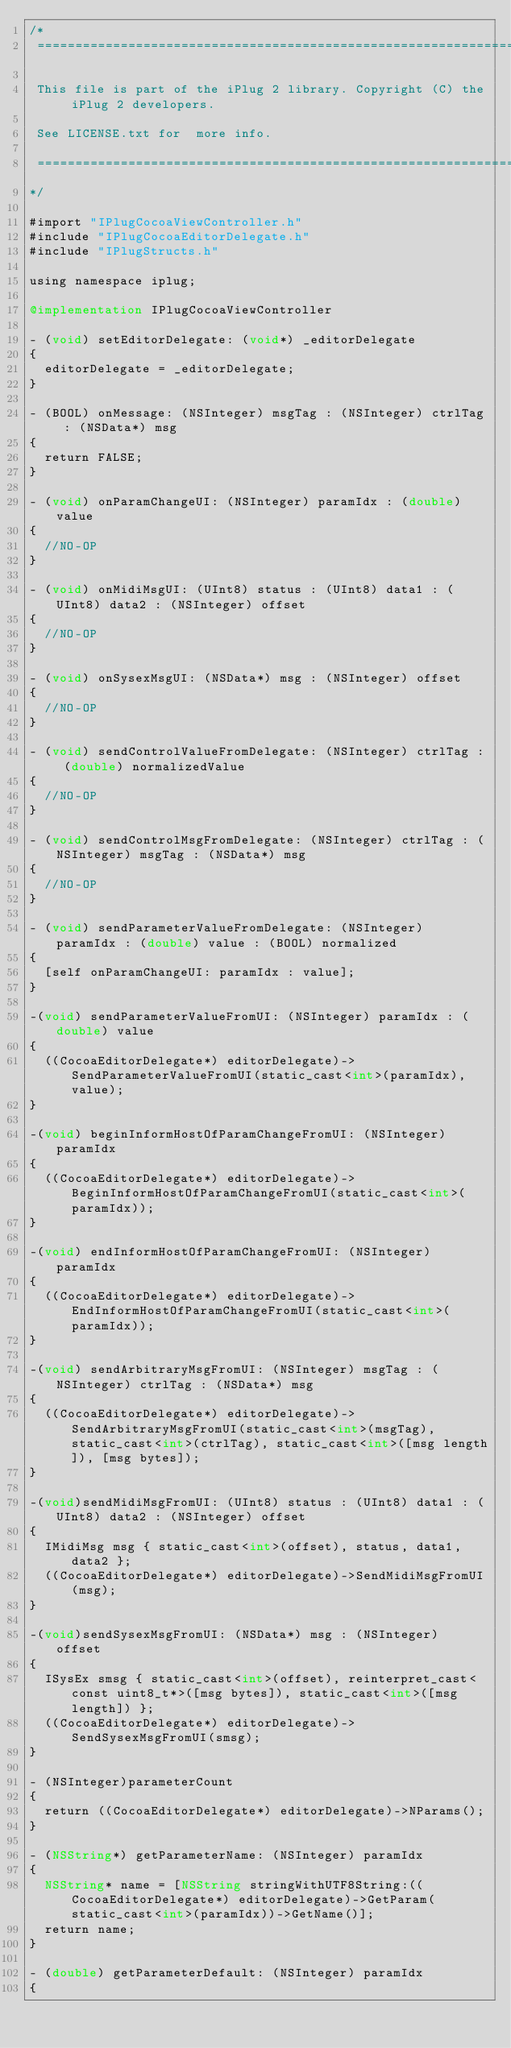<code> <loc_0><loc_0><loc_500><loc_500><_ObjectiveC_>/*
 ==============================================================================
 
 This file is part of the iPlug 2 library. Copyright (C) the iPlug 2 developers.
 
 See LICENSE.txt for  more info.
 
 ==============================================================================
*/

#import "IPlugCocoaViewController.h"
#include "IPlugCocoaEditorDelegate.h"
#include "IPlugStructs.h"

using namespace iplug;

@implementation IPlugCocoaViewController

- (void) setEditorDelegate: (void*) _editorDelegate
{
  editorDelegate = _editorDelegate;
}

- (BOOL) onMessage: (NSInteger) msgTag : (NSInteger) ctrlTag : (NSData*) msg
{
  return FALSE;
}

- (void) onParamChangeUI: (NSInteger) paramIdx : (double) value
{
  //NO-OP
}

- (void) onMidiMsgUI: (UInt8) status : (UInt8) data1 : (UInt8) data2 : (NSInteger) offset
{
  //NO-OP
}

- (void) onSysexMsgUI: (NSData*) msg : (NSInteger) offset
{
  //NO-OP
}

- (void) sendControlValueFromDelegate: (NSInteger) ctrlTag : (double) normalizedValue
{
  //NO-OP
}

- (void) sendControlMsgFromDelegate: (NSInteger) ctrlTag : (NSInteger) msgTag : (NSData*) msg
{
  //NO-OP
}

- (void) sendParameterValueFromDelegate: (NSInteger) paramIdx : (double) value : (BOOL) normalized
{
  [self onParamChangeUI: paramIdx : value];
}

-(void) sendParameterValueFromUI: (NSInteger) paramIdx : (double) value
{
  ((CocoaEditorDelegate*) editorDelegate)->SendParameterValueFromUI(static_cast<int>(paramIdx), value);
}

-(void) beginInformHostOfParamChangeFromUI: (NSInteger) paramIdx
{
  ((CocoaEditorDelegate*) editorDelegate)->BeginInformHostOfParamChangeFromUI(static_cast<int>(paramIdx));
}

-(void) endInformHostOfParamChangeFromUI: (NSInteger) paramIdx
{
  ((CocoaEditorDelegate*) editorDelegate)->EndInformHostOfParamChangeFromUI(static_cast<int>(paramIdx));
}

-(void) sendArbitraryMsgFromUI: (NSInteger) msgTag : (NSInteger) ctrlTag : (NSData*) msg
{
  ((CocoaEditorDelegate*) editorDelegate)->SendArbitraryMsgFromUI(static_cast<int>(msgTag), static_cast<int>(ctrlTag), static_cast<int>([msg length]), [msg bytes]);
}

-(void)sendMidiMsgFromUI: (UInt8) status : (UInt8) data1 : (UInt8) data2 : (NSInteger) offset
{
  IMidiMsg msg { static_cast<int>(offset), status, data1, data2 };
  ((CocoaEditorDelegate*) editorDelegate)->SendMidiMsgFromUI(msg);
}

-(void)sendSysexMsgFromUI: (NSData*) msg : (NSInteger) offset
{
  ISysEx smsg { static_cast<int>(offset), reinterpret_cast<const uint8_t*>([msg bytes]), static_cast<int>([msg length]) };
  ((CocoaEditorDelegate*) editorDelegate)->SendSysexMsgFromUI(smsg);
}

- (NSInteger)parameterCount
{
  return ((CocoaEditorDelegate*) editorDelegate)->NParams();
}

- (NSString*) getParameterName: (NSInteger) paramIdx
{
  NSString* name = [NSString stringWithUTF8String:((CocoaEditorDelegate*) editorDelegate)->GetParam(static_cast<int>(paramIdx))->GetName()];
  return name;
}

- (double) getParameterDefault: (NSInteger) paramIdx
{</code> 